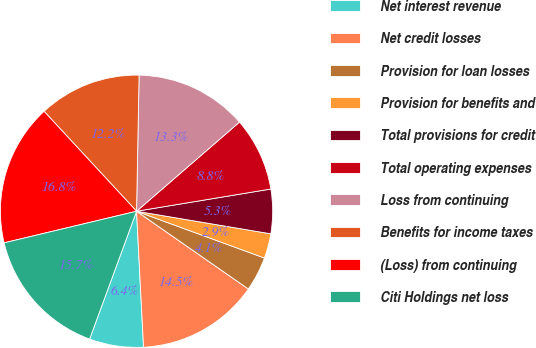<chart> <loc_0><loc_0><loc_500><loc_500><pie_chart><fcel>Net interest revenue<fcel>Net credit losses<fcel>Provision for loan losses<fcel>Provision for benefits and<fcel>Total provisions for credit<fcel>Total operating expenses<fcel>Loss from continuing<fcel>Benefits for income taxes<fcel>(Loss) from continuing<fcel>Citi Holdings net loss<nl><fcel>6.42%<fcel>14.51%<fcel>4.09%<fcel>2.93%<fcel>5.26%<fcel>8.75%<fcel>13.34%<fcel>12.18%<fcel>16.84%<fcel>15.67%<nl></chart> 